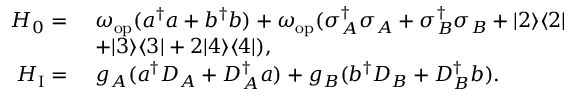Convert formula to latex. <formula><loc_0><loc_0><loc_500><loc_500>\begin{array} { r l } { H _ { 0 } = } & { \omega _ { o p } ( a ^ { \dagger } a + b ^ { \dagger } b ) + \omega _ { o p } ( \sigma _ { A } ^ { \dagger } \sigma _ { A } + \sigma _ { B } ^ { \dagger } \sigma _ { B } + | 2 \rangle \langle 2 | } \\ & { + | 3 \rangle \langle 3 | + 2 | 4 \rangle \langle 4 | ) , } \\ { H _ { I } = } & { g _ { A } ( a ^ { \dagger } D _ { A } + D _ { A } ^ { \dagger } a ) + g _ { B } ( b ^ { \dagger } D _ { B } + D _ { B } ^ { \dagger } b ) . } \end{array}</formula> 